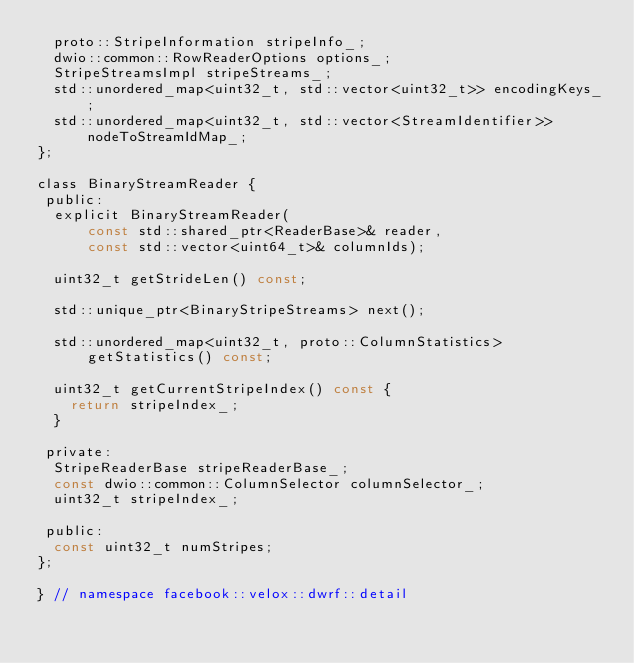<code> <loc_0><loc_0><loc_500><loc_500><_C_>  proto::StripeInformation stripeInfo_;
  dwio::common::RowReaderOptions options_;
  StripeStreamsImpl stripeStreams_;
  std::unordered_map<uint32_t, std::vector<uint32_t>> encodingKeys_;
  std::unordered_map<uint32_t, std::vector<StreamIdentifier>>
      nodeToStreamIdMap_;
};

class BinaryStreamReader {
 public:
  explicit BinaryStreamReader(
      const std::shared_ptr<ReaderBase>& reader,
      const std::vector<uint64_t>& columnIds);

  uint32_t getStrideLen() const;

  std::unique_ptr<BinaryStripeStreams> next();

  std::unordered_map<uint32_t, proto::ColumnStatistics> getStatistics() const;

  uint32_t getCurrentStripeIndex() const {
    return stripeIndex_;
  }

 private:
  StripeReaderBase stripeReaderBase_;
  const dwio::common::ColumnSelector columnSelector_;
  uint32_t stripeIndex_;

 public:
  const uint32_t numStripes;
};

} // namespace facebook::velox::dwrf::detail
</code> 